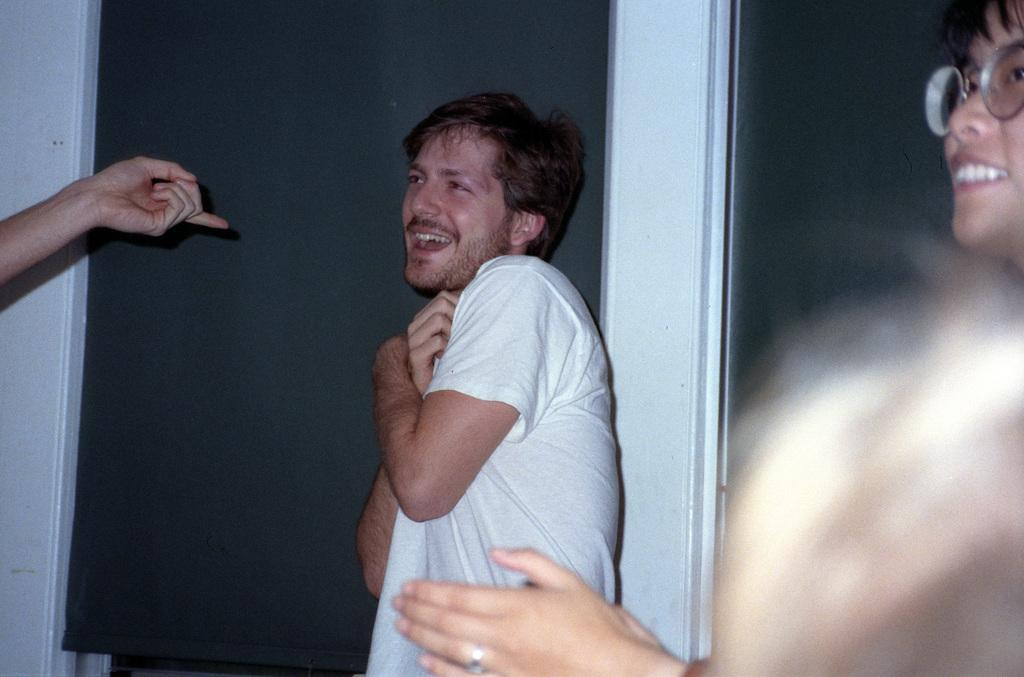Who can be seen in the image? There are people in the image. Can you describe the man among them? A man is standing among them, and he is wearing a white color T-shirt. What is the current state of the man's mind in the image? There is no information provided about the man's mental state in the image, so it cannot be determined. 